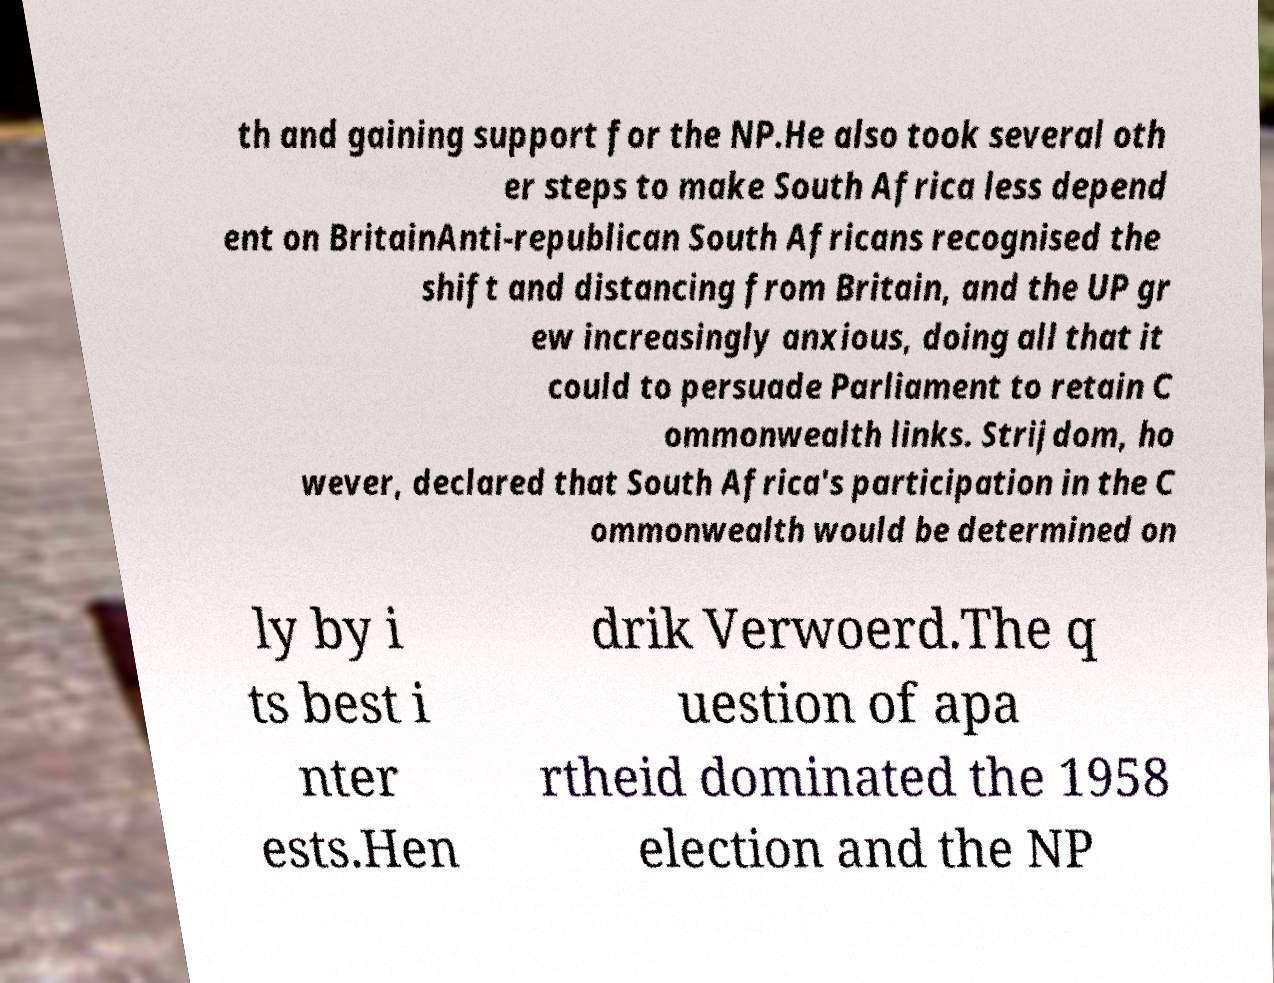What messages or text are displayed in this image? I need them in a readable, typed format. th and gaining support for the NP.He also took several oth er steps to make South Africa less depend ent on BritainAnti-republican South Africans recognised the shift and distancing from Britain, and the UP gr ew increasingly anxious, doing all that it could to persuade Parliament to retain C ommonwealth links. Strijdom, ho wever, declared that South Africa's participation in the C ommonwealth would be determined on ly by i ts best i nter ests.Hen drik Verwoerd.The q uestion of apa rtheid dominated the 1958 election and the NP 